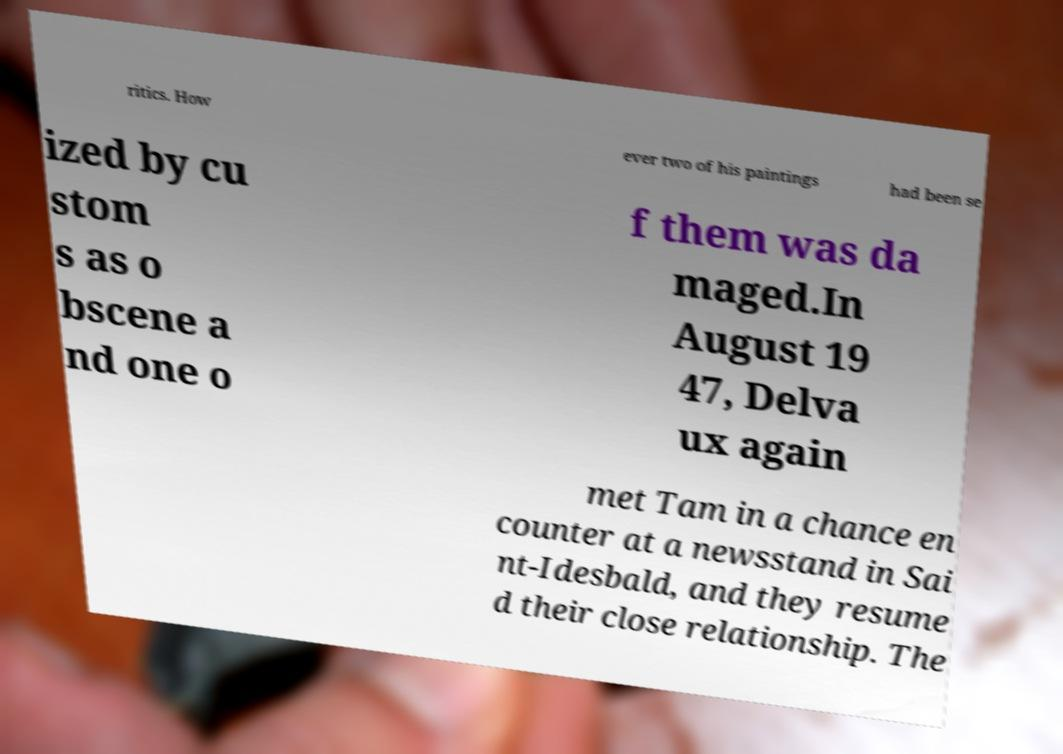Could you extract and type out the text from this image? ritics. How ever two of his paintings had been se ized by cu stom s as o bscene a nd one o f them was da maged.In August 19 47, Delva ux again met Tam in a chance en counter at a newsstand in Sai nt-Idesbald, and they resume d their close relationship. The 